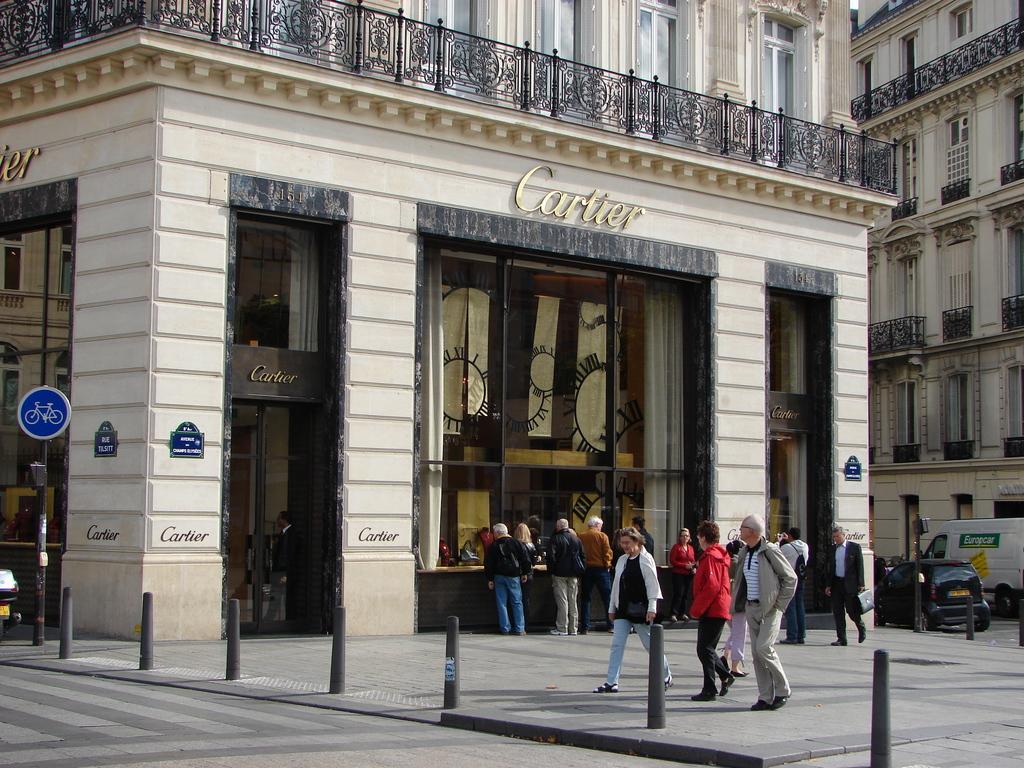In one or two sentences, can you explain what this image depicts? In the image there are two huge buildings, in front of the first building there are few people, behind them there are vehicles on the road and in the front there is a board attached to the pole on the left side. 